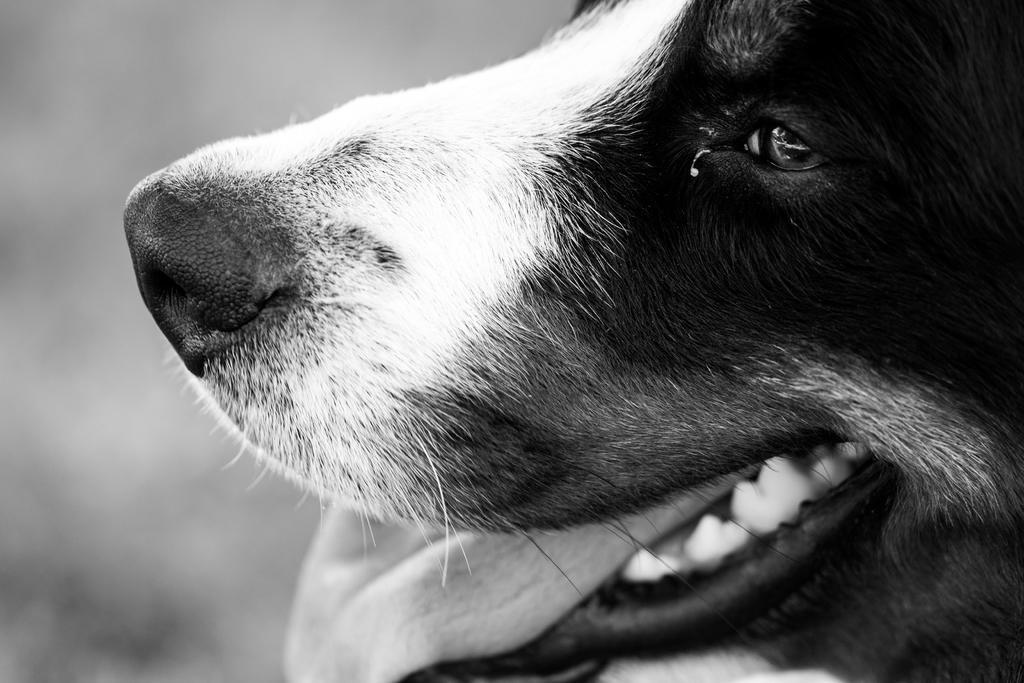In one or two sentences, can you explain what this image depicts? In the image in the center, we can see one dog, which is in black and white color. 